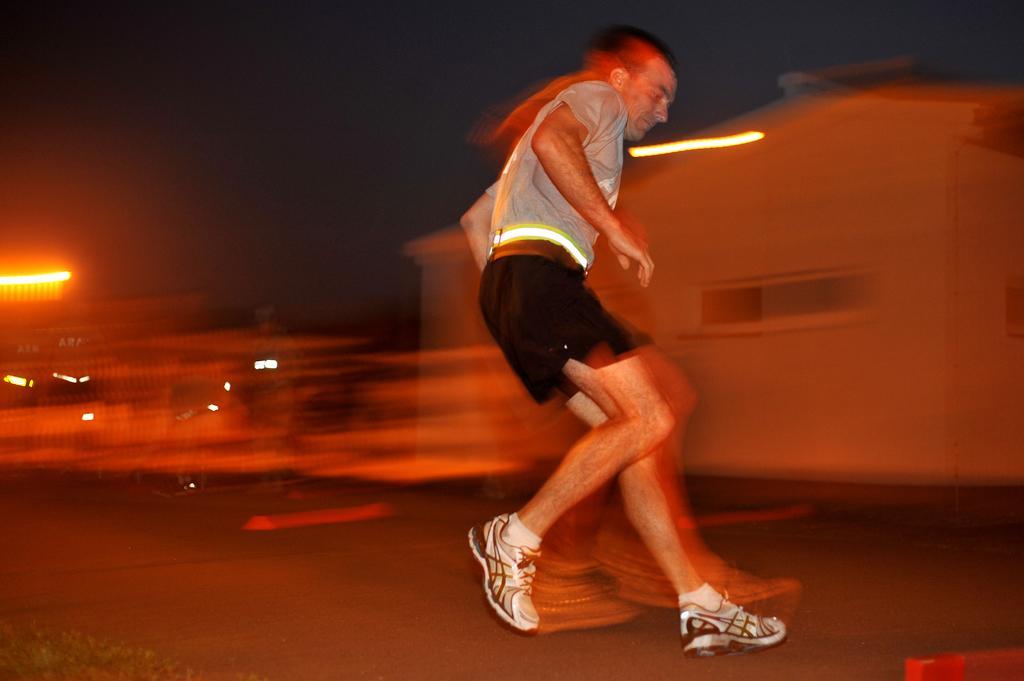Could you give a brief overview of what you see in this image? In the image there is a man in grey t-shirt and shorts running on the road and behind there is a building with lights, this is clicked at night time. 